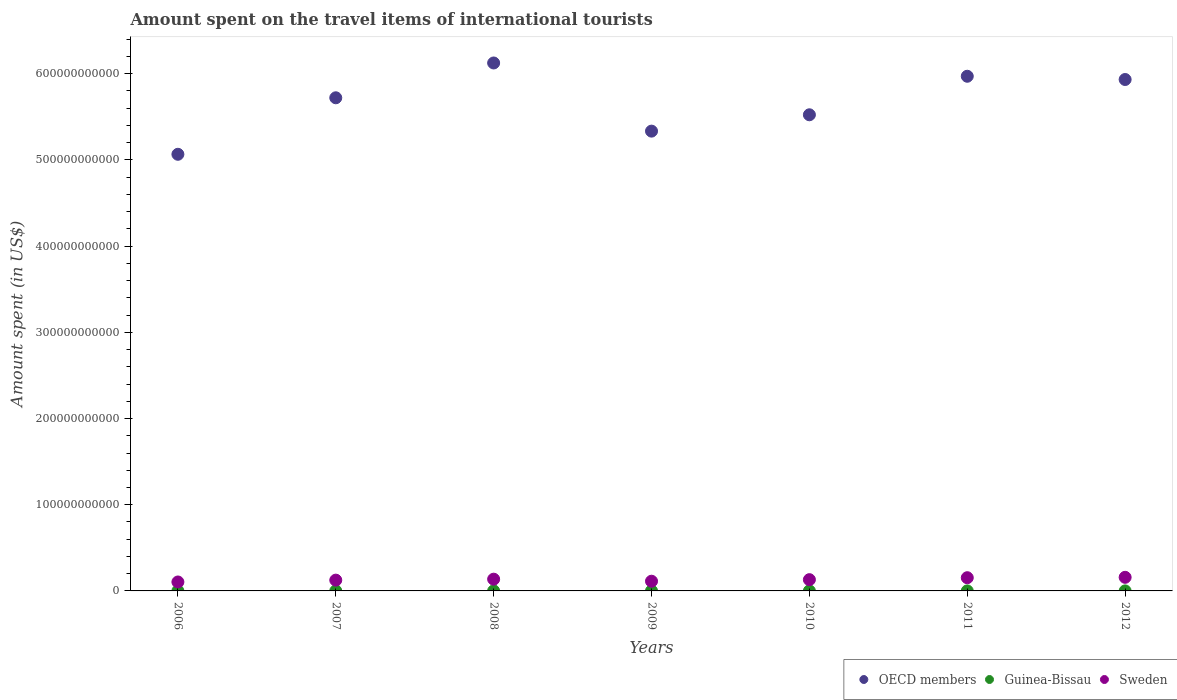Is the number of dotlines equal to the number of legend labels?
Provide a short and direct response. Yes. What is the amount spent on the travel items of international tourists in Guinea-Bissau in 2010?
Offer a very short reply. 2.94e+07. Across all years, what is the maximum amount spent on the travel items of international tourists in Guinea-Bissau?
Make the answer very short. 4.56e+07. Across all years, what is the minimum amount spent on the travel items of international tourists in Guinea-Bissau?
Your answer should be very brief. 1.55e+07. In which year was the amount spent on the travel items of international tourists in OECD members maximum?
Provide a succinct answer. 2008. In which year was the amount spent on the travel items of international tourists in Guinea-Bissau minimum?
Your response must be concise. 2006. What is the total amount spent on the travel items of international tourists in OECD members in the graph?
Your answer should be compact. 3.97e+12. What is the difference between the amount spent on the travel items of international tourists in Guinea-Bissau in 2009 and that in 2010?
Your response must be concise. -3.70e+06. What is the difference between the amount spent on the travel items of international tourists in Sweden in 2011 and the amount spent on the travel items of international tourists in Guinea-Bissau in 2007?
Make the answer very short. 1.53e+1. What is the average amount spent on the travel items of international tourists in Sweden per year?
Your response must be concise. 1.31e+1. In the year 2012, what is the difference between the amount spent on the travel items of international tourists in OECD members and amount spent on the travel items of international tourists in Sweden?
Offer a very short reply. 5.78e+11. In how many years, is the amount spent on the travel items of international tourists in OECD members greater than 320000000000 US$?
Offer a terse response. 7. What is the ratio of the amount spent on the travel items of international tourists in Guinea-Bissau in 2006 to that in 2007?
Offer a terse response. 0.39. Is the amount spent on the travel items of international tourists in Guinea-Bissau in 2010 less than that in 2011?
Provide a short and direct response. Yes. Is the difference between the amount spent on the travel items of international tourists in OECD members in 2009 and 2012 greater than the difference between the amount spent on the travel items of international tourists in Sweden in 2009 and 2012?
Ensure brevity in your answer.  No. What is the difference between the highest and the second highest amount spent on the travel items of international tourists in Sweden?
Provide a short and direct response. 4.50e+08. What is the difference between the highest and the lowest amount spent on the travel items of international tourists in Guinea-Bissau?
Your answer should be very brief. 3.01e+07. In how many years, is the amount spent on the travel items of international tourists in Guinea-Bissau greater than the average amount spent on the travel items of international tourists in Guinea-Bissau taken over all years?
Give a very brief answer. 3. Is the amount spent on the travel items of international tourists in OECD members strictly less than the amount spent on the travel items of international tourists in Guinea-Bissau over the years?
Provide a succinct answer. No. How many years are there in the graph?
Provide a succinct answer. 7. What is the difference between two consecutive major ticks on the Y-axis?
Your answer should be compact. 1.00e+11. Are the values on the major ticks of Y-axis written in scientific E-notation?
Provide a short and direct response. No. Does the graph contain any zero values?
Provide a short and direct response. No. How many legend labels are there?
Provide a short and direct response. 3. How are the legend labels stacked?
Your answer should be very brief. Horizontal. What is the title of the graph?
Keep it short and to the point. Amount spent on the travel items of international tourists. Does "Qatar" appear as one of the legend labels in the graph?
Provide a short and direct response. No. What is the label or title of the Y-axis?
Give a very brief answer. Amount spent (in US$). What is the Amount spent (in US$) in OECD members in 2006?
Provide a short and direct response. 5.07e+11. What is the Amount spent (in US$) in Guinea-Bissau in 2006?
Make the answer very short. 1.55e+07. What is the Amount spent (in US$) in Sweden in 2006?
Give a very brief answer. 1.04e+1. What is the Amount spent (in US$) in OECD members in 2007?
Ensure brevity in your answer.  5.72e+11. What is the Amount spent (in US$) in Guinea-Bissau in 2007?
Provide a short and direct response. 4.02e+07. What is the Amount spent (in US$) in Sweden in 2007?
Provide a succinct answer. 1.25e+1. What is the Amount spent (in US$) in OECD members in 2008?
Offer a terse response. 6.12e+11. What is the Amount spent (in US$) in Guinea-Bissau in 2008?
Ensure brevity in your answer.  4.56e+07. What is the Amount spent (in US$) in Sweden in 2008?
Keep it short and to the point. 1.36e+1. What is the Amount spent (in US$) of OECD members in 2009?
Offer a terse response. 5.33e+11. What is the Amount spent (in US$) in Guinea-Bissau in 2009?
Make the answer very short. 2.57e+07. What is the Amount spent (in US$) of Sweden in 2009?
Provide a short and direct response. 1.13e+1. What is the Amount spent (in US$) in OECD members in 2010?
Ensure brevity in your answer.  5.52e+11. What is the Amount spent (in US$) of Guinea-Bissau in 2010?
Your answer should be compact. 2.94e+07. What is the Amount spent (in US$) in Sweden in 2010?
Make the answer very short. 1.31e+1. What is the Amount spent (in US$) in OECD members in 2011?
Keep it short and to the point. 5.97e+11. What is the Amount spent (in US$) in Guinea-Bissau in 2011?
Make the answer very short. 3.15e+07. What is the Amount spent (in US$) in Sweden in 2011?
Ensure brevity in your answer.  1.53e+1. What is the Amount spent (in US$) in OECD members in 2012?
Keep it short and to the point. 5.93e+11. What is the Amount spent (in US$) in Guinea-Bissau in 2012?
Your answer should be compact. 1.98e+07. What is the Amount spent (in US$) of Sweden in 2012?
Make the answer very short. 1.58e+1. Across all years, what is the maximum Amount spent (in US$) in OECD members?
Keep it short and to the point. 6.12e+11. Across all years, what is the maximum Amount spent (in US$) of Guinea-Bissau?
Ensure brevity in your answer.  4.56e+07. Across all years, what is the maximum Amount spent (in US$) of Sweden?
Keep it short and to the point. 1.58e+1. Across all years, what is the minimum Amount spent (in US$) in OECD members?
Your answer should be very brief. 5.07e+11. Across all years, what is the minimum Amount spent (in US$) in Guinea-Bissau?
Offer a very short reply. 1.55e+07. Across all years, what is the minimum Amount spent (in US$) in Sweden?
Offer a terse response. 1.04e+1. What is the total Amount spent (in US$) of OECD members in the graph?
Ensure brevity in your answer.  3.97e+12. What is the total Amount spent (in US$) of Guinea-Bissau in the graph?
Keep it short and to the point. 2.08e+08. What is the total Amount spent (in US$) of Sweden in the graph?
Your response must be concise. 9.20e+1. What is the difference between the Amount spent (in US$) of OECD members in 2006 and that in 2007?
Give a very brief answer. -6.55e+1. What is the difference between the Amount spent (in US$) in Guinea-Bissau in 2006 and that in 2007?
Offer a terse response. -2.47e+07. What is the difference between the Amount spent (in US$) in Sweden in 2006 and that in 2007?
Make the answer very short. -2.13e+09. What is the difference between the Amount spent (in US$) in OECD members in 2006 and that in 2008?
Give a very brief answer. -1.06e+11. What is the difference between the Amount spent (in US$) of Guinea-Bissau in 2006 and that in 2008?
Provide a short and direct response. -3.01e+07. What is the difference between the Amount spent (in US$) in Sweden in 2006 and that in 2008?
Make the answer very short. -3.25e+09. What is the difference between the Amount spent (in US$) of OECD members in 2006 and that in 2009?
Ensure brevity in your answer.  -2.69e+1. What is the difference between the Amount spent (in US$) in Guinea-Bissau in 2006 and that in 2009?
Give a very brief answer. -1.02e+07. What is the difference between the Amount spent (in US$) of Sweden in 2006 and that in 2009?
Offer a very short reply. -8.90e+08. What is the difference between the Amount spent (in US$) of OECD members in 2006 and that in 2010?
Your response must be concise. -4.58e+1. What is the difference between the Amount spent (in US$) in Guinea-Bissau in 2006 and that in 2010?
Keep it short and to the point. -1.39e+07. What is the difference between the Amount spent (in US$) of Sweden in 2006 and that in 2010?
Give a very brief answer. -2.69e+09. What is the difference between the Amount spent (in US$) in OECD members in 2006 and that in 2011?
Offer a very short reply. -9.05e+1. What is the difference between the Amount spent (in US$) of Guinea-Bissau in 2006 and that in 2011?
Your response must be concise. -1.60e+07. What is the difference between the Amount spent (in US$) of Sweden in 2006 and that in 2011?
Offer a very short reply. -4.95e+09. What is the difference between the Amount spent (in US$) of OECD members in 2006 and that in 2012?
Provide a succinct answer. -8.68e+1. What is the difference between the Amount spent (in US$) in Guinea-Bissau in 2006 and that in 2012?
Your response must be concise. -4.30e+06. What is the difference between the Amount spent (in US$) of Sweden in 2006 and that in 2012?
Provide a short and direct response. -5.40e+09. What is the difference between the Amount spent (in US$) in OECD members in 2007 and that in 2008?
Make the answer very short. -4.04e+1. What is the difference between the Amount spent (in US$) in Guinea-Bissau in 2007 and that in 2008?
Provide a short and direct response. -5.40e+06. What is the difference between the Amount spent (in US$) in Sweden in 2007 and that in 2008?
Offer a terse response. -1.12e+09. What is the difference between the Amount spent (in US$) of OECD members in 2007 and that in 2009?
Offer a terse response. 3.87e+1. What is the difference between the Amount spent (in US$) in Guinea-Bissau in 2007 and that in 2009?
Make the answer very short. 1.45e+07. What is the difference between the Amount spent (in US$) in Sweden in 2007 and that in 2009?
Make the answer very short. 1.24e+09. What is the difference between the Amount spent (in US$) in OECD members in 2007 and that in 2010?
Give a very brief answer. 1.97e+1. What is the difference between the Amount spent (in US$) of Guinea-Bissau in 2007 and that in 2010?
Your answer should be compact. 1.08e+07. What is the difference between the Amount spent (in US$) of Sweden in 2007 and that in 2010?
Your response must be concise. -5.53e+08. What is the difference between the Amount spent (in US$) of OECD members in 2007 and that in 2011?
Give a very brief answer. -2.50e+1. What is the difference between the Amount spent (in US$) of Guinea-Bissau in 2007 and that in 2011?
Keep it short and to the point. 8.70e+06. What is the difference between the Amount spent (in US$) of Sweden in 2007 and that in 2011?
Ensure brevity in your answer.  -2.81e+09. What is the difference between the Amount spent (in US$) of OECD members in 2007 and that in 2012?
Make the answer very short. -2.12e+1. What is the difference between the Amount spent (in US$) of Guinea-Bissau in 2007 and that in 2012?
Your answer should be compact. 2.04e+07. What is the difference between the Amount spent (in US$) of Sweden in 2007 and that in 2012?
Ensure brevity in your answer.  -3.26e+09. What is the difference between the Amount spent (in US$) of OECD members in 2008 and that in 2009?
Your answer should be very brief. 7.91e+1. What is the difference between the Amount spent (in US$) in Guinea-Bissau in 2008 and that in 2009?
Keep it short and to the point. 1.99e+07. What is the difference between the Amount spent (in US$) of Sweden in 2008 and that in 2009?
Offer a terse response. 2.36e+09. What is the difference between the Amount spent (in US$) in OECD members in 2008 and that in 2010?
Provide a short and direct response. 6.01e+1. What is the difference between the Amount spent (in US$) of Guinea-Bissau in 2008 and that in 2010?
Your answer should be compact. 1.62e+07. What is the difference between the Amount spent (in US$) in Sweden in 2008 and that in 2010?
Provide a short and direct response. 5.65e+08. What is the difference between the Amount spent (in US$) in OECD members in 2008 and that in 2011?
Your response must be concise. 1.54e+1. What is the difference between the Amount spent (in US$) of Guinea-Bissau in 2008 and that in 2011?
Provide a short and direct response. 1.41e+07. What is the difference between the Amount spent (in US$) of Sweden in 2008 and that in 2011?
Give a very brief answer. -1.70e+09. What is the difference between the Amount spent (in US$) in OECD members in 2008 and that in 2012?
Your answer should be very brief. 1.92e+1. What is the difference between the Amount spent (in US$) of Guinea-Bissau in 2008 and that in 2012?
Keep it short and to the point. 2.58e+07. What is the difference between the Amount spent (in US$) in Sweden in 2008 and that in 2012?
Your response must be concise. -2.15e+09. What is the difference between the Amount spent (in US$) of OECD members in 2009 and that in 2010?
Ensure brevity in your answer.  -1.90e+1. What is the difference between the Amount spent (in US$) of Guinea-Bissau in 2009 and that in 2010?
Offer a very short reply. -3.70e+06. What is the difference between the Amount spent (in US$) in Sweden in 2009 and that in 2010?
Your response must be concise. -1.80e+09. What is the difference between the Amount spent (in US$) in OECD members in 2009 and that in 2011?
Ensure brevity in your answer.  -6.37e+1. What is the difference between the Amount spent (in US$) of Guinea-Bissau in 2009 and that in 2011?
Make the answer very short. -5.80e+06. What is the difference between the Amount spent (in US$) in Sweden in 2009 and that in 2011?
Keep it short and to the point. -4.06e+09. What is the difference between the Amount spent (in US$) in OECD members in 2009 and that in 2012?
Your response must be concise. -5.99e+1. What is the difference between the Amount spent (in US$) in Guinea-Bissau in 2009 and that in 2012?
Ensure brevity in your answer.  5.90e+06. What is the difference between the Amount spent (in US$) in Sweden in 2009 and that in 2012?
Your answer should be compact. -4.51e+09. What is the difference between the Amount spent (in US$) in OECD members in 2010 and that in 2011?
Provide a short and direct response. -4.47e+1. What is the difference between the Amount spent (in US$) of Guinea-Bissau in 2010 and that in 2011?
Offer a terse response. -2.10e+06. What is the difference between the Amount spent (in US$) of Sweden in 2010 and that in 2011?
Your answer should be compact. -2.26e+09. What is the difference between the Amount spent (in US$) in OECD members in 2010 and that in 2012?
Provide a succinct answer. -4.09e+1. What is the difference between the Amount spent (in US$) in Guinea-Bissau in 2010 and that in 2012?
Your answer should be very brief. 9.60e+06. What is the difference between the Amount spent (in US$) of Sweden in 2010 and that in 2012?
Provide a succinct answer. -2.71e+09. What is the difference between the Amount spent (in US$) of OECD members in 2011 and that in 2012?
Keep it short and to the point. 3.77e+09. What is the difference between the Amount spent (in US$) of Guinea-Bissau in 2011 and that in 2012?
Offer a terse response. 1.17e+07. What is the difference between the Amount spent (in US$) of Sweden in 2011 and that in 2012?
Make the answer very short. -4.50e+08. What is the difference between the Amount spent (in US$) in OECD members in 2006 and the Amount spent (in US$) in Guinea-Bissau in 2007?
Ensure brevity in your answer.  5.07e+11. What is the difference between the Amount spent (in US$) in OECD members in 2006 and the Amount spent (in US$) in Sweden in 2007?
Offer a terse response. 4.94e+11. What is the difference between the Amount spent (in US$) in Guinea-Bissau in 2006 and the Amount spent (in US$) in Sweden in 2007?
Your answer should be compact. -1.25e+1. What is the difference between the Amount spent (in US$) in OECD members in 2006 and the Amount spent (in US$) in Guinea-Bissau in 2008?
Provide a succinct answer. 5.06e+11. What is the difference between the Amount spent (in US$) in OECD members in 2006 and the Amount spent (in US$) in Sweden in 2008?
Your response must be concise. 4.93e+11. What is the difference between the Amount spent (in US$) in Guinea-Bissau in 2006 and the Amount spent (in US$) in Sweden in 2008?
Your response must be concise. -1.36e+1. What is the difference between the Amount spent (in US$) in OECD members in 2006 and the Amount spent (in US$) in Guinea-Bissau in 2009?
Offer a terse response. 5.07e+11. What is the difference between the Amount spent (in US$) of OECD members in 2006 and the Amount spent (in US$) of Sweden in 2009?
Give a very brief answer. 4.95e+11. What is the difference between the Amount spent (in US$) in Guinea-Bissau in 2006 and the Amount spent (in US$) in Sweden in 2009?
Keep it short and to the point. -1.13e+1. What is the difference between the Amount spent (in US$) of OECD members in 2006 and the Amount spent (in US$) of Guinea-Bissau in 2010?
Provide a short and direct response. 5.07e+11. What is the difference between the Amount spent (in US$) of OECD members in 2006 and the Amount spent (in US$) of Sweden in 2010?
Your answer should be compact. 4.93e+11. What is the difference between the Amount spent (in US$) of Guinea-Bissau in 2006 and the Amount spent (in US$) of Sweden in 2010?
Ensure brevity in your answer.  -1.30e+1. What is the difference between the Amount spent (in US$) of OECD members in 2006 and the Amount spent (in US$) of Guinea-Bissau in 2011?
Your response must be concise. 5.07e+11. What is the difference between the Amount spent (in US$) of OECD members in 2006 and the Amount spent (in US$) of Sweden in 2011?
Give a very brief answer. 4.91e+11. What is the difference between the Amount spent (in US$) of Guinea-Bissau in 2006 and the Amount spent (in US$) of Sweden in 2011?
Provide a succinct answer. -1.53e+1. What is the difference between the Amount spent (in US$) in OECD members in 2006 and the Amount spent (in US$) in Guinea-Bissau in 2012?
Keep it short and to the point. 5.07e+11. What is the difference between the Amount spent (in US$) of OECD members in 2006 and the Amount spent (in US$) of Sweden in 2012?
Provide a succinct answer. 4.91e+11. What is the difference between the Amount spent (in US$) in Guinea-Bissau in 2006 and the Amount spent (in US$) in Sweden in 2012?
Give a very brief answer. -1.58e+1. What is the difference between the Amount spent (in US$) in OECD members in 2007 and the Amount spent (in US$) in Guinea-Bissau in 2008?
Your answer should be compact. 5.72e+11. What is the difference between the Amount spent (in US$) in OECD members in 2007 and the Amount spent (in US$) in Sweden in 2008?
Make the answer very short. 5.58e+11. What is the difference between the Amount spent (in US$) of Guinea-Bissau in 2007 and the Amount spent (in US$) of Sweden in 2008?
Your answer should be very brief. -1.36e+1. What is the difference between the Amount spent (in US$) in OECD members in 2007 and the Amount spent (in US$) in Guinea-Bissau in 2009?
Provide a short and direct response. 5.72e+11. What is the difference between the Amount spent (in US$) of OECD members in 2007 and the Amount spent (in US$) of Sweden in 2009?
Provide a succinct answer. 5.61e+11. What is the difference between the Amount spent (in US$) in Guinea-Bissau in 2007 and the Amount spent (in US$) in Sweden in 2009?
Offer a very short reply. -1.12e+1. What is the difference between the Amount spent (in US$) of OECD members in 2007 and the Amount spent (in US$) of Guinea-Bissau in 2010?
Your response must be concise. 5.72e+11. What is the difference between the Amount spent (in US$) of OECD members in 2007 and the Amount spent (in US$) of Sweden in 2010?
Ensure brevity in your answer.  5.59e+11. What is the difference between the Amount spent (in US$) in Guinea-Bissau in 2007 and the Amount spent (in US$) in Sweden in 2010?
Provide a short and direct response. -1.30e+1. What is the difference between the Amount spent (in US$) of OECD members in 2007 and the Amount spent (in US$) of Guinea-Bissau in 2011?
Your answer should be compact. 5.72e+11. What is the difference between the Amount spent (in US$) in OECD members in 2007 and the Amount spent (in US$) in Sweden in 2011?
Give a very brief answer. 5.57e+11. What is the difference between the Amount spent (in US$) of Guinea-Bissau in 2007 and the Amount spent (in US$) of Sweden in 2011?
Keep it short and to the point. -1.53e+1. What is the difference between the Amount spent (in US$) in OECD members in 2007 and the Amount spent (in US$) in Guinea-Bissau in 2012?
Offer a terse response. 5.72e+11. What is the difference between the Amount spent (in US$) in OECD members in 2007 and the Amount spent (in US$) in Sweden in 2012?
Offer a terse response. 5.56e+11. What is the difference between the Amount spent (in US$) in Guinea-Bissau in 2007 and the Amount spent (in US$) in Sweden in 2012?
Provide a succinct answer. -1.57e+1. What is the difference between the Amount spent (in US$) of OECD members in 2008 and the Amount spent (in US$) of Guinea-Bissau in 2009?
Make the answer very short. 6.12e+11. What is the difference between the Amount spent (in US$) in OECD members in 2008 and the Amount spent (in US$) in Sweden in 2009?
Your response must be concise. 6.01e+11. What is the difference between the Amount spent (in US$) of Guinea-Bissau in 2008 and the Amount spent (in US$) of Sweden in 2009?
Ensure brevity in your answer.  -1.12e+1. What is the difference between the Amount spent (in US$) of OECD members in 2008 and the Amount spent (in US$) of Guinea-Bissau in 2010?
Offer a very short reply. 6.12e+11. What is the difference between the Amount spent (in US$) in OECD members in 2008 and the Amount spent (in US$) in Sweden in 2010?
Keep it short and to the point. 5.99e+11. What is the difference between the Amount spent (in US$) in Guinea-Bissau in 2008 and the Amount spent (in US$) in Sweden in 2010?
Keep it short and to the point. -1.30e+1. What is the difference between the Amount spent (in US$) of OECD members in 2008 and the Amount spent (in US$) of Guinea-Bissau in 2011?
Your answer should be compact. 6.12e+11. What is the difference between the Amount spent (in US$) in OECD members in 2008 and the Amount spent (in US$) in Sweden in 2011?
Keep it short and to the point. 5.97e+11. What is the difference between the Amount spent (in US$) of Guinea-Bissau in 2008 and the Amount spent (in US$) of Sweden in 2011?
Make the answer very short. -1.53e+1. What is the difference between the Amount spent (in US$) in OECD members in 2008 and the Amount spent (in US$) in Guinea-Bissau in 2012?
Keep it short and to the point. 6.12e+11. What is the difference between the Amount spent (in US$) in OECD members in 2008 and the Amount spent (in US$) in Sweden in 2012?
Your answer should be very brief. 5.97e+11. What is the difference between the Amount spent (in US$) of Guinea-Bissau in 2008 and the Amount spent (in US$) of Sweden in 2012?
Make the answer very short. -1.57e+1. What is the difference between the Amount spent (in US$) in OECD members in 2009 and the Amount spent (in US$) in Guinea-Bissau in 2010?
Your answer should be compact. 5.33e+11. What is the difference between the Amount spent (in US$) of OECD members in 2009 and the Amount spent (in US$) of Sweden in 2010?
Ensure brevity in your answer.  5.20e+11. What is the difference between the Amount spent (in US$) of Guinea-Bissau in 2009 and the Amount spent (in US$) of Sweden in 2010?
Make the answer very short. -1.30e+1. What is the difference between the Amount spent (in US$) in OECD members in 2009 and the Amount spent (in US$) in Guinea-Bissau in 2011?
Give a very brief answer. 5.33e+11. What is the difference between the Amount spent (in US$) of OECD members in 2009 and the Amount spent (in US$) of Sweden in 2011?
Ensure brevity in your answer.  5.18e+11. What is the difference between the Amount spent (in US$) of Guinea-Bissau in 2009 and the Amount spent (in US$) of Sweden in 2011?
Offer a terse response. -1.53e+1. What is the difference between the Amount spent (in US$) in OECD members in 2009 and the Amount spent (in US$) in Guinea-Bissau in 2012?
Make the answer very short. 5.33e+11. What is the difference between the Amount spent (in US$) of OECD members in 2009 and the Amount spent (in US$) of Sweden in 2012?
Keep it short and to the point. 5.18e+11. What is the difference between the Amount spent (in US$) of Guinea-Bissau in 2009 and the Amount spent (in US$) of Sweden in 2012?
Your response must be concise. -1.58e+1. What is the difference between the Amount spent (in US$) in OECD members in 2010 and the Amount spent (in US$) in Guinea-Bissau in 2011?
Offer a very short reply. 5.52e+11. What is the difference between the Amount spent (in US$) of OECD members in 2010 and the Amount spent (in US$) of Sweden in 2011?
Keep it short and to the point. 5.37e+11. What is the difference between the Amount spent (in US$) in Guinea-Bissau in 2010 and the Amount spent (in US$) in Sweden in 2011?
Your answer should be compact. -1.53e+1. What is the difference between the Amount spent (in US$) in OECD members in 2010 and the Amount spent (in US$) in Guinea-Bissau in 2012?
Give a very brief answer. 5.52e+11. What is the difference between the Amount spent (in US$) in OECD members in 2010 and the Amount spent (in US$) in Sweden in 2012?
Ensure brevity in your answer.  5.37e+11. What is the difference between the Amount spent (in US$) of Guinea-Bissau in 2010 and the Amount spent (in US$) of Sweden in 2012?
Provide a short and direct response. -1.57e+1. What is the difference between the Amount spent (in US$) of OECD members in 2011 and the Amount spent (in US$) of Guinea-Bissau in 2012?
Give a very brief answer. 5.97e+11. What is the difference between the Amount spent (in US$) in OECD members in 2011 and the Amount spent (in US$) in Sweden in 2012?
Your answer should be very brief. 5.81e+11. What is the difference between the Amount spent (in US$) in Guinea-Bissau in 2011 and the Amount spent (in US$) in Sweden in 2012?
Provide a short and direct response. -1.57e+1. What is the average Amount spent (in US$) of OECD members per year?
Make the answer very short. 5.67e+11. What is the average Amount spent (in US$) in Guinea-Bissau per year?
Your answer should be very brief. 2.97e+07. What is the average Amount spent (in US$) in Sweden per year?
Provide a short and direct response. 1.31e+1. In the year 2006, what is the difference between the Amount spent (in US$) in OECD members and Amount spent (in US$) in Guinea-Bissau?
Give a very brief answer. 5.07e+11. In the year 2006, what is the difference between the Amount spent (in US$) in OECD members and Amount spent (in US$) in Sweden?
Give a very brief answer. 4.96e+11. In the year 2006, what is the difference between the Amount spent (in US$) in Guinea-Bissau and Amount spent (in US$) in Sweden?
Provide a succinct answer. -1.04e+1. In the year 2007, what is the difference between the Amount spent (in US$) in OECD members and Amount spent (in US$) in Guinea-Bissau?
Give a very brief answer. 5.72e+11. In the year 2007, what is the difference between the Amount spent (in US$) in OECD members and Amount spent (in US$) in Sweden?
Offer a terse response. 5.60e+11. In the year 2007, what is the difference between the Amount spent (in US$) in Guinea-Bissau and Amount spent (in US$) in Sweden?
Make the answer very short. -1.25e+1. In the year 2008, what is the difference between the Amount spent (in US$) in OECD members and Amount spent (in US$) in Guinea-Bissau?
Your response must be concise. 6.12e+11. In the year 2008, what is the difference between the Amount spent (in US$) in OECD members and Amount spent (in US$) in Sweden?
Offer a terse response. 5.99e+11. In the year 2008, what is the difference between the Amount spent (in US$) of Guinea-Bissau and Amount spent (in US$) of Sweden?
Your answer should be compact. -1.36e+1. In the year 2009, what is the difference between the Amount spent (in US$) in OECD members and Amount spent (in US$) in Guinea-Bissau?
Offer a terse response. 5.33e+11. In the year 2009, what is the difference between the Amount spent (in US$) of OECD members and Amount spent (in US$) of Sweden?
Offer a terse response. 5.22e+11. In the year 2009, what is the difference between the Amount spent (in US$) of Guinea-Bissau and Amount spent (in US$) of Sweden?
Ensure brevity in your answer.  -1.12e+1. In the year 2010, what is the difference between the Amount spent (in US$) in OECD members and Amount spent (in US$) in Guinea-Bissau?
Your answer should be very brief. 5.52e+11. In the year 2010, what is the difference between the Amount spent (in US$) in OECD members and Amount spent (in US$) in Sweden?
Offer a very short reply. 5.39e+11. In the year 2010, what is the difference between the Amount spent (in US$) of Guinea-Bissau and Amount spent (in US$) of Sweden?
Keep it short and to the point. -1.30e+1. In the year 2011, what is the difference between the Amount spent (in US$) of OECD members and Amount spent (in US$) of Guinea-Bissau?
Give a very brief answer. 5.97e+11. In the year 2011, what is the difference between the Amount spent (in US$) of OECD members and Amount spent (in US$) of Sweden?
Your answer should be compact. 5.82e+11. In the year 2011, what is the difference between the Amount spent (in US$) in Guinea-Bissau and Amount spent (in US$) in Sweden?
Ensure brevity in your answer.  -1.53e+1. In the year 2012, what is the difference between the Amount spent (in US$) of OECD members and Amount spent (in US$) of Guinea-Bissau?
Your answer should be very brief. 5.93e+11. In the year 2012, what is the difference between the Amount spent (in US$) in OECD members and Amount spent (in US$) in Sweden?
Your answer should be very brief. 5.78e+11. In the year 2012, what is the difference between the Amount spent (in US$) in Guinea-Bissau and Amount spent (in US$) in Sweden?
Make the answer very short. -1.58e+1. What is the ratio of the Amount spent (in US$) of OECD members in 2006 to that in 2007?
Your answer should be compact. 0.89. What is the ratio of the Amount spent (in US$) of Guinea-Bissau in 2006 to that in 2007?
Keep it short and to the point. 0.39. What is the ratio of the Amount spent (in US$) in Sweden in 2006 to that in 2007?
Ensure brevity in your answer.  0.83. What is the ratio of the Amount spent (in US$) in OECD members in 2006 to that in 2008?
Your answer should be compact. 0.83. What is the ratio of the Amount spent (in US$) in Guinea-Bissau in 2006 to that in 2008?
Offer a very short reply. 0.34. What is the ratio of the Amount spent (in US$) of Sweden in 2006 to that in 2008?
Keep it short and to the point. 0.76. What is the ratio of the Amount spent (in US$) of OECD members in 2006 to that in 2009?
Your response must be concise. 0.95. What is the ratio of the Amount spent (in US$) in Guinea-Bissau in 2006 to that in 2009?
Provide a short and direct response. 0.6. What is the ratio of the Amount spent (in US$) of Sweden in 2006 to that in 2009?
Make the answer very short. 0.92. What is the ratio of the Amount spent (in US$) of OECD members in 2006 to that in 2010?
Offer a terse response. 0.92. What is the ratio of the Amount spent (in US$) of Guinea-Bissau in 2006 to that in 2010?
Your answer should be very brief. 0.53. What is the ratio of the Amount spent (in US$) of Sweden in 2006 to that in 2010?
Offer a very short reply. 0.79. What is the ratio of the Amount spent (in US$) of OECD members in 2006 to that in 2011?
Your answer should be compact. 0.85. What is the ratio of the Amount spent (in US$) in Guinea-Bissau in 2006 to that in 2011?
Offer a very short reply. 0.49. What is the ratio of the Amount spent (in US$) in Sweden in 2006 to that in 2011?
Your answer should be compact. 0.68. What is the ratio of the Amount spent (in US$) of OECD members in 2006 to that in 2012?
Ensure brevity in your answer.  0.85. What is the ratio of the Amount spent (in US$) in Guinea-Bissau in 2006 to that in 2012?
Give a very brief answer. 0.78. What is the ratio of the Amount spent (in US$) of Sweden in 2006 to that in 2012?
Your response must be concise. 0.66. What is the ratio of the Amount spent (in US$) of OECD members in 2007 to that in 2008?
Keep it short and to the point. 0.93. What is the ratio of the Amount spent (in US$) in Guinea-Bissau in 2007 to that in 2008?
Provide a succinct answer. 0.88. What is the ratio of the Amount spent (in US$) in Sweden in 2007 to that in 2008?
Provide a succinct answer. 0.92. What is the ratio of the Amount spent (in US$) in OECD members in 2007 to that in 2009?
Your answer should be very brief. 1.07. What is the ratio of the Amount spent (in US$) of Guinea-Bissau in 2007 to that in 2009?
Provide a succinct answer. 1.56. What is the ratio of the Amount spent (in US$) in Sweden in 2007 to that in 2009?
Your answer should be compact. 1.11. What is the ratio of the Amount spent (in US$) of OECD members in 2007 to that in 2010?
Provide a short and direct response. 1.04. What is the ratio of the Amount spent (in US$) of Guinea-Bissau in 2007 to that in 2010?
Keep it short and to the point. 1.37. What is the ratio of the Amount spent (in US$) in Sweden in 2007 to that in 2010?
Offer a terse response. 0.96. What is the ratio of the Amount spent (in US$) of OECD members in 2007 to that in 2011?
Provide a succinct answer. 0.96. What is the ratio of the Amount spent (in US$) of Guinea-Bissau in 2007 to that in 2011?
Keep it short and to the point. 1.28. What is the ratio of the Amount spent (in US$) in Sweden in 2007 to that in 2011?
Give a very brief answer. 0.82. What is the ratio of the Amount spent (in US$) of Guinea-Bissau in 2007 to that in 2012?
Give a very brief answer. 2.03. What is the ratio of the Amount spent (in US$) in Sweden in 2007 to that in 2012?
Ensure brevity in your answer.  0.79. What is the ratio of the Amount spent (in US$) in OECD members in 2008 to that in 2009?
Offer a very short reply. 1.15. What is the ratio of the Amount spent (in US$) of Guinea-Bissau in 2008 to that in 2009?
Offer a terse response. 1.77. What is the ratio of the Amount spent (in US$) of Sweden in 2008 to that in 2009?
Your response must be concise. 1.21. What is the ratio of the Amount spent (in US$) in OECD members in 2008 to that in 2010?
Offer a very short reply. 1.11. What is the ratio of the Amount spent (in US$) of Guinea-Bissau in 2008 to that in 2010?
Your response must be concise. 1.55. What is the ratio of the Amount spent (in US$) of Sweden in 2008 to that in 2010?
Provide a short and direct response. 1.04. What is the ratio of the Amount spent (in US$) of OECD members in 2008 to that in 2011?
Make the answer very short. 1.03. What is the ratio of the Amount spent (in US$) in Guinea-Bissau in 2008 to that in 2011?
Your answer should be very brief. 1.45. What is the ratio of the Amount spent (in US$) of Sweden in 2008 to that in 2011?
Make the answer very short. 0.89. What is the ratio of the Amount spent (in US$) in OECD members in 2008 to that in 2012?
Provide a succinct answer. 1.03. What is the ratio of the Amount spent (in US$) in Guinea-Bissau in 2008 to that in 2012?
Give a very brief answer. 2.3. What is the ratio of the Amount spent (in US$) in Sweden in 2008 to that in 2012?
Your response must be concise. 0.86. What is the ratio of the Amount spent (in US$) in OECD members in 2009 to that in 2010?
Give a very brief answer. 0.97. What is the ratio of the Amount spent (in US$) in Guinea-Bissau in 2009 to that in 2010?
Provide a short and direct response. 0.87. What is the ratio of the Amount spent (in US$) in Sweden in 2009 to that in 2010?
Ensure brevity in your answer.  0.86. What is the ratio of the Amount spent (in US$) of OECD members in 2009 to that in 2011?
Ensure brevity in your answer.  0.89. What is the ratio of the Amount spent (in US$) in Guinea-Bissau in 2009 to that in 2011?
Offer a very short reply. 0.82. What is the ratio of the Amount spent (in US$) of Sweden in 2009 to that in 2011?
Your answer should be very brief. 0.74. What is the ratio of the Amount spent (in US$) in OECD members in 2009 to that in 2012?
Provide a short and direct response. 0.9. What is the ratio of the Amount spent (in US$) of Guinea-Bissau in 2009 to that in 2012?
Your answer should be very brief. 1.3. What is the ratio of the Amount spent (in US$) in Sweden in 2009 to that in 2012?
Provide a succinct answer. 0.71. What is the ratio of the Amount spent (in US$) of OECD members in 2010 to that in 2011?
Make the answer very short. 0.93. What is the ratio of the Amount spent (in US$) of Guinea-Bissau in 2010 to that in 2011?
Provide a succinct answer. 0.93. What is the ratio of the Amount spent (in US$) of Sweden in 2010 to that in 2011?
Offer a very short reply. 0.85. What is the ratio of the Amount spent (in US$) of Guinea-Bissau in 2010 to that in 2012?
Your answer should be compact. 1.48. What is the ratio of the Amount spent (in US$) of Sweden in 2010 to that in 2012?
Provide a succinct answer. 0.83. What is the ratio of the Amount spent (in US$) of OECD members in 2011 to that in 2012?
Provide a succinct answer. 1.01. What is the ratio of the Amount spent (in US$) of Guinea-Bissau in 2011 to that in 2012?
Your answer should be very brief. 1.59. What is the ratio of the Amount spent (in US$) in Sweden in 2011 to that in 2012?
Keep it short and to the point. 0.97. What is the difference between the highest and the second highest Amount spent (in US$) in OECD members?
Ensure brevity in your answer.  1.54e+1. What is the difference between the highest and the second highest Amount spent (in US$) in Guinea-Bissau?
Your answer should be very brief. 5.40e+06. What is the difference between the highest and the second highest Amount spent (in US$) in Sweden?
Your answer should be very brief. 4.50e+08. What is the difference between the highest and the lowest Amount spent (in US$) in OECD members?
Provide a succinct answer. 1.06e+11. What is the difference between the highest and the lowest Amount spent (in US$) in Guinea-Bissau?
Make the answer very short. 3.01e+07. What is the difference between the highest and the lowest Amount spent (in US$) of Sweden?
Provide a succinct answer. 5.40e+09. 